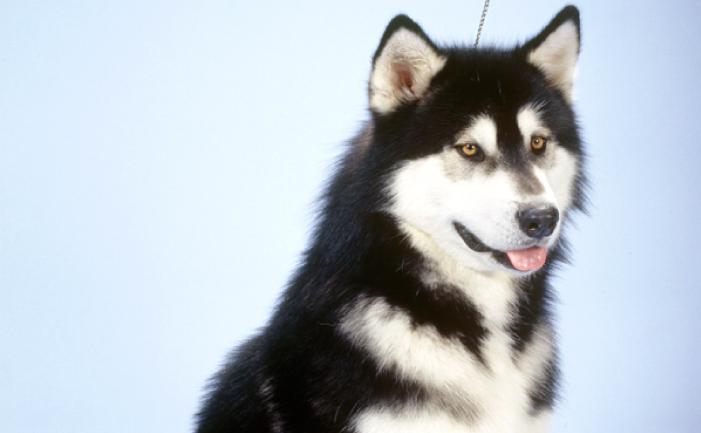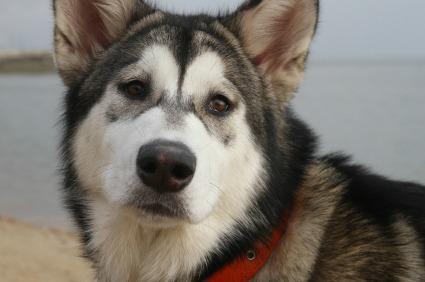The first image is the image on the left, the second image is the image on the right. Considering the images on both sides, is "In the image to the right you can see the dog's tongue." valid? Answer yes or no. No. The first image is the image on the left, the second image is the image on the right. Analyze the images presented: Is the assertion "Each image features only one dog, and the dog on the left has an open mouth, while the dog on the right has a closed mouth." valid? Answer yes or no. Yes. 